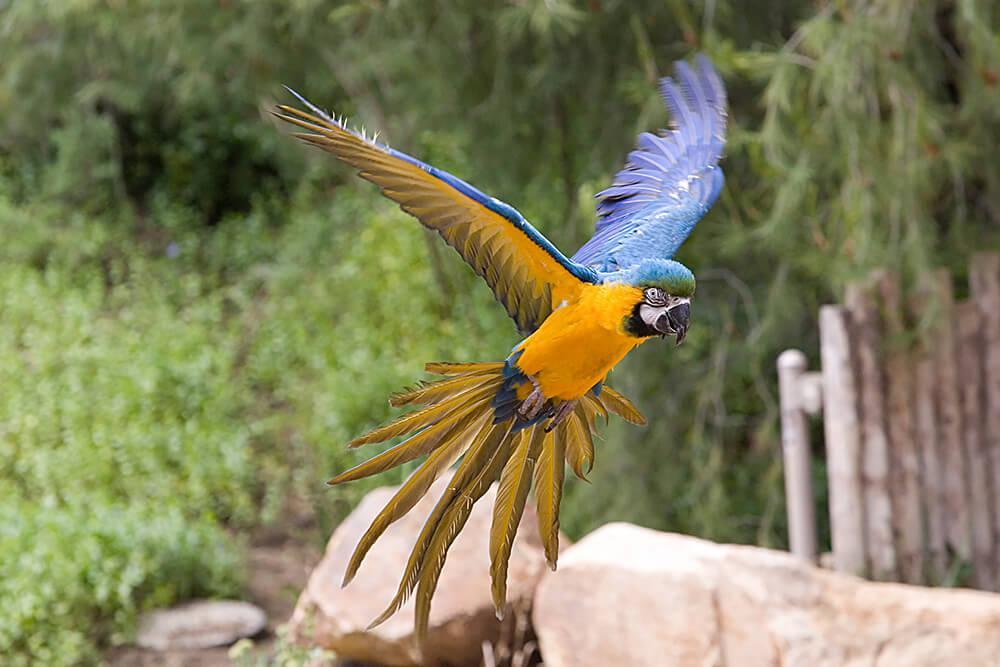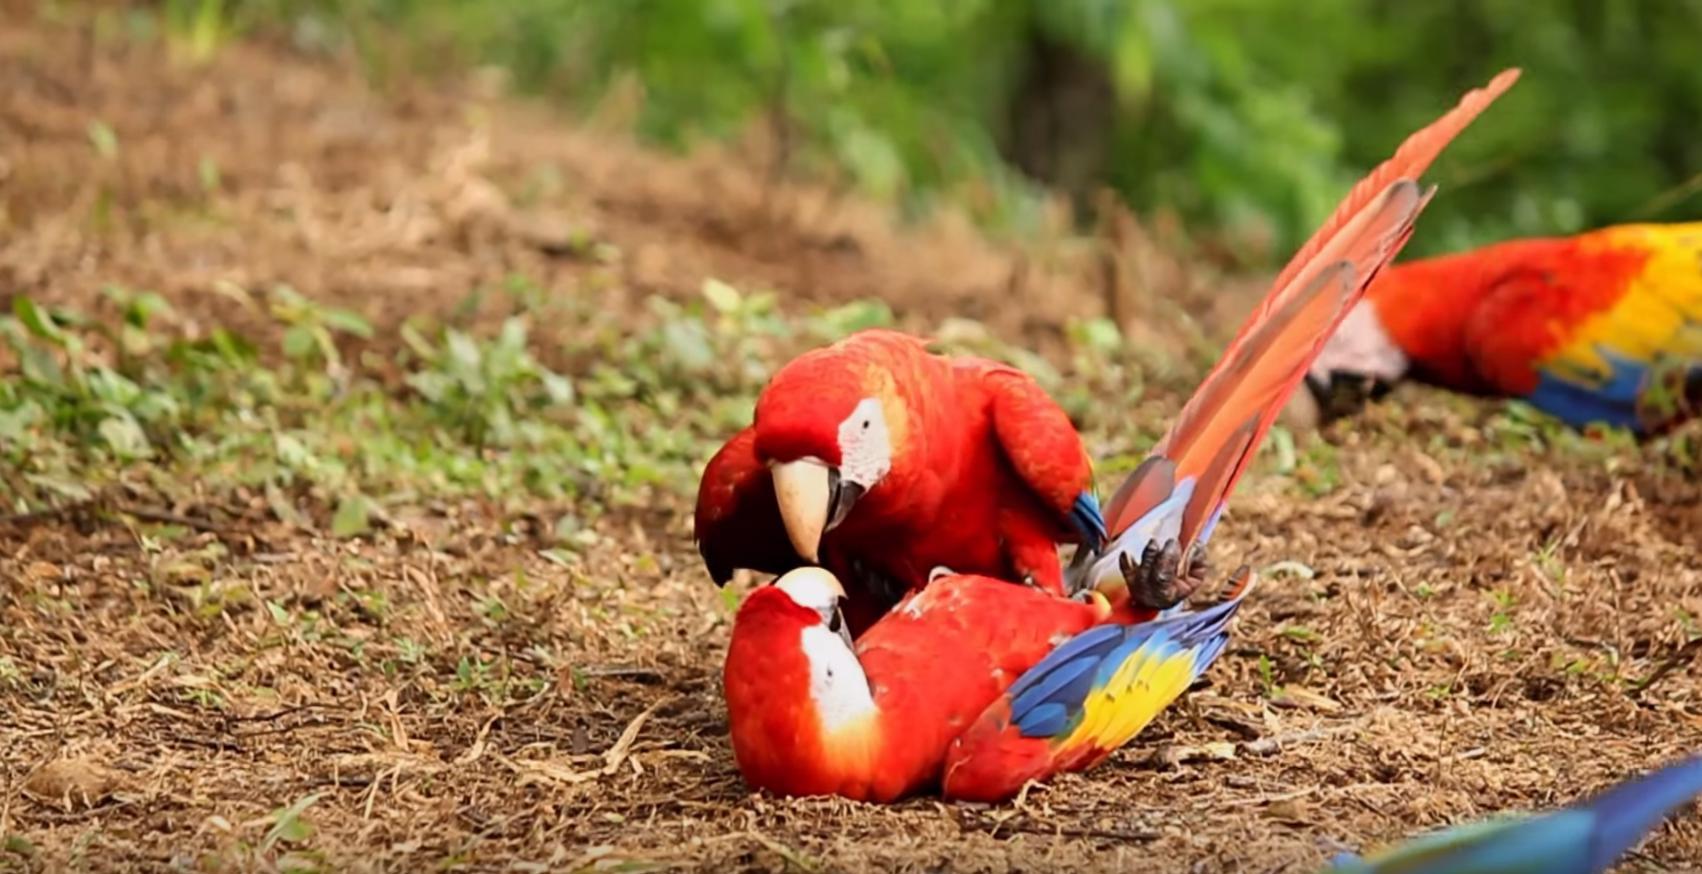The first image is the image on the left, the second image is the image on the right. Assess this claim about the two images: "The left image shows a parrot with wings extended in flight.". Correct or not? Answer yes or no. Yes. 